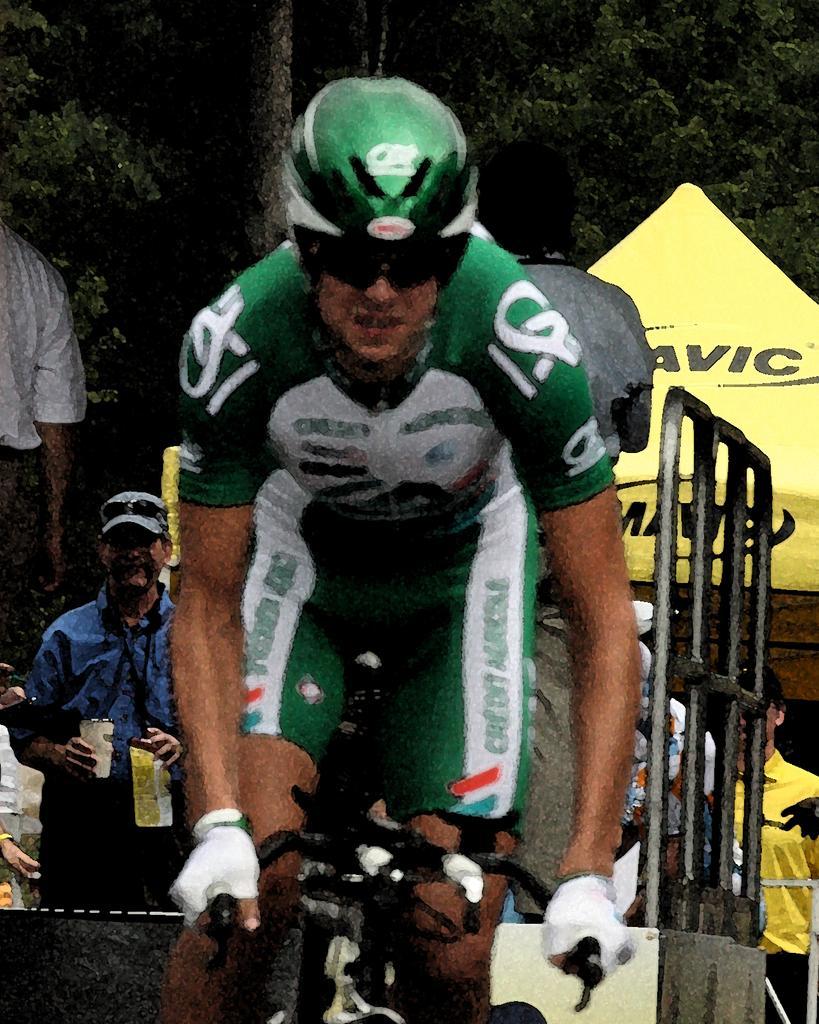Please provide a concise description of this image. In this image we can see a man is cycling. He is wearing green and white color dress with green helmet. We can see grille, people, shelter and trees in the background. 